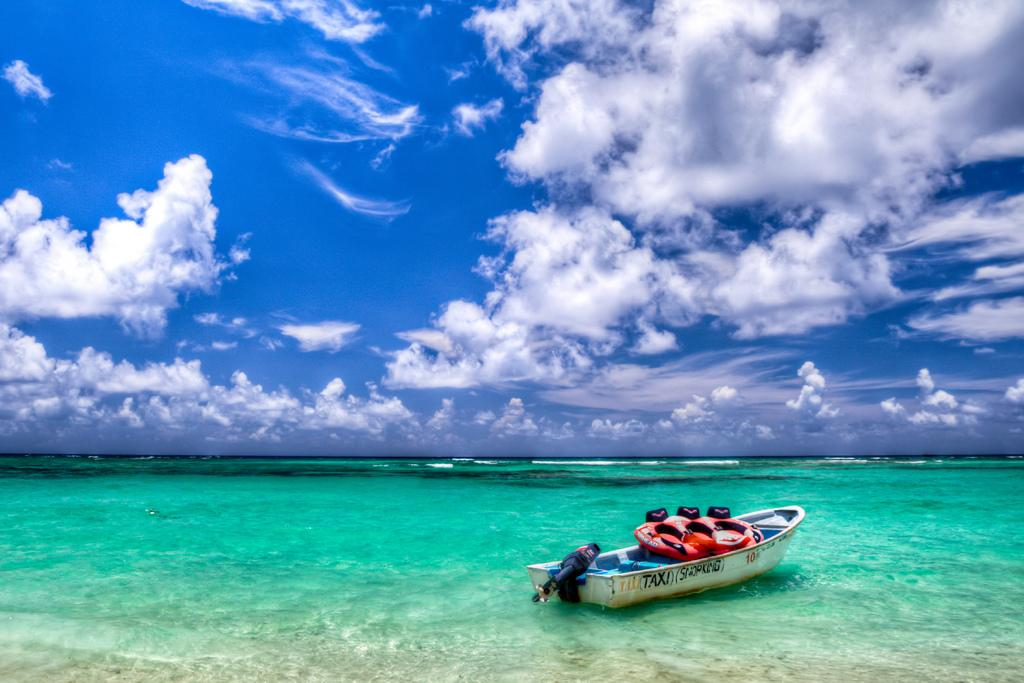<image>
Share a concise interpretation of the image provided. the word taxi is on the side of a boat 